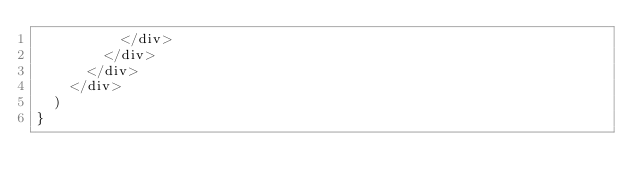<code> <loc_0><loc_0><loc_500><loc_500><_JavaScript_>          </div>
        </div>
      </div>
    </div>
  )
}
</code> 